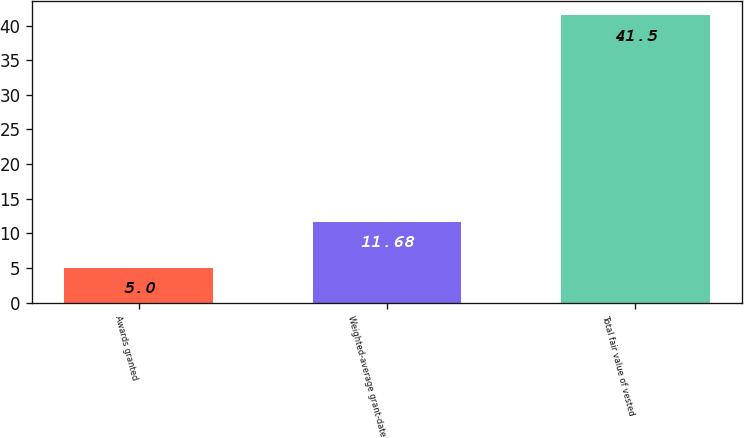<chart> <loc_0><loc_0><loc_500><loc_500><bar_chart><fcel>Awards granted<fcel>Weighted-average grant-date<fcel>Total fair value of vested<nl><fcel>5<fcel>11.68<fcel>41.5<nl></chart> 